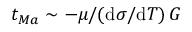<formula> <loc_0><loc_0><loc_500><loc_500>t _ { M a } \sim - \mu / ( d \sigma / d T ) \, G</formula> 